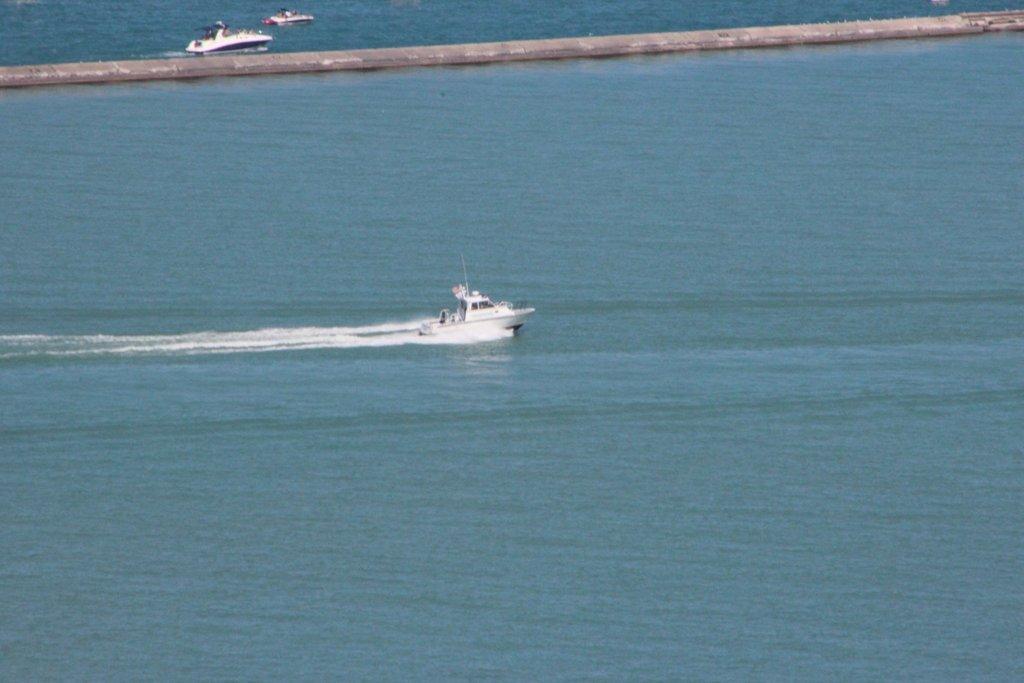How would you summarize this image in a sentence or two? In this image we can see some boats in a large water body. On the backside we can see a walkway bridge. 